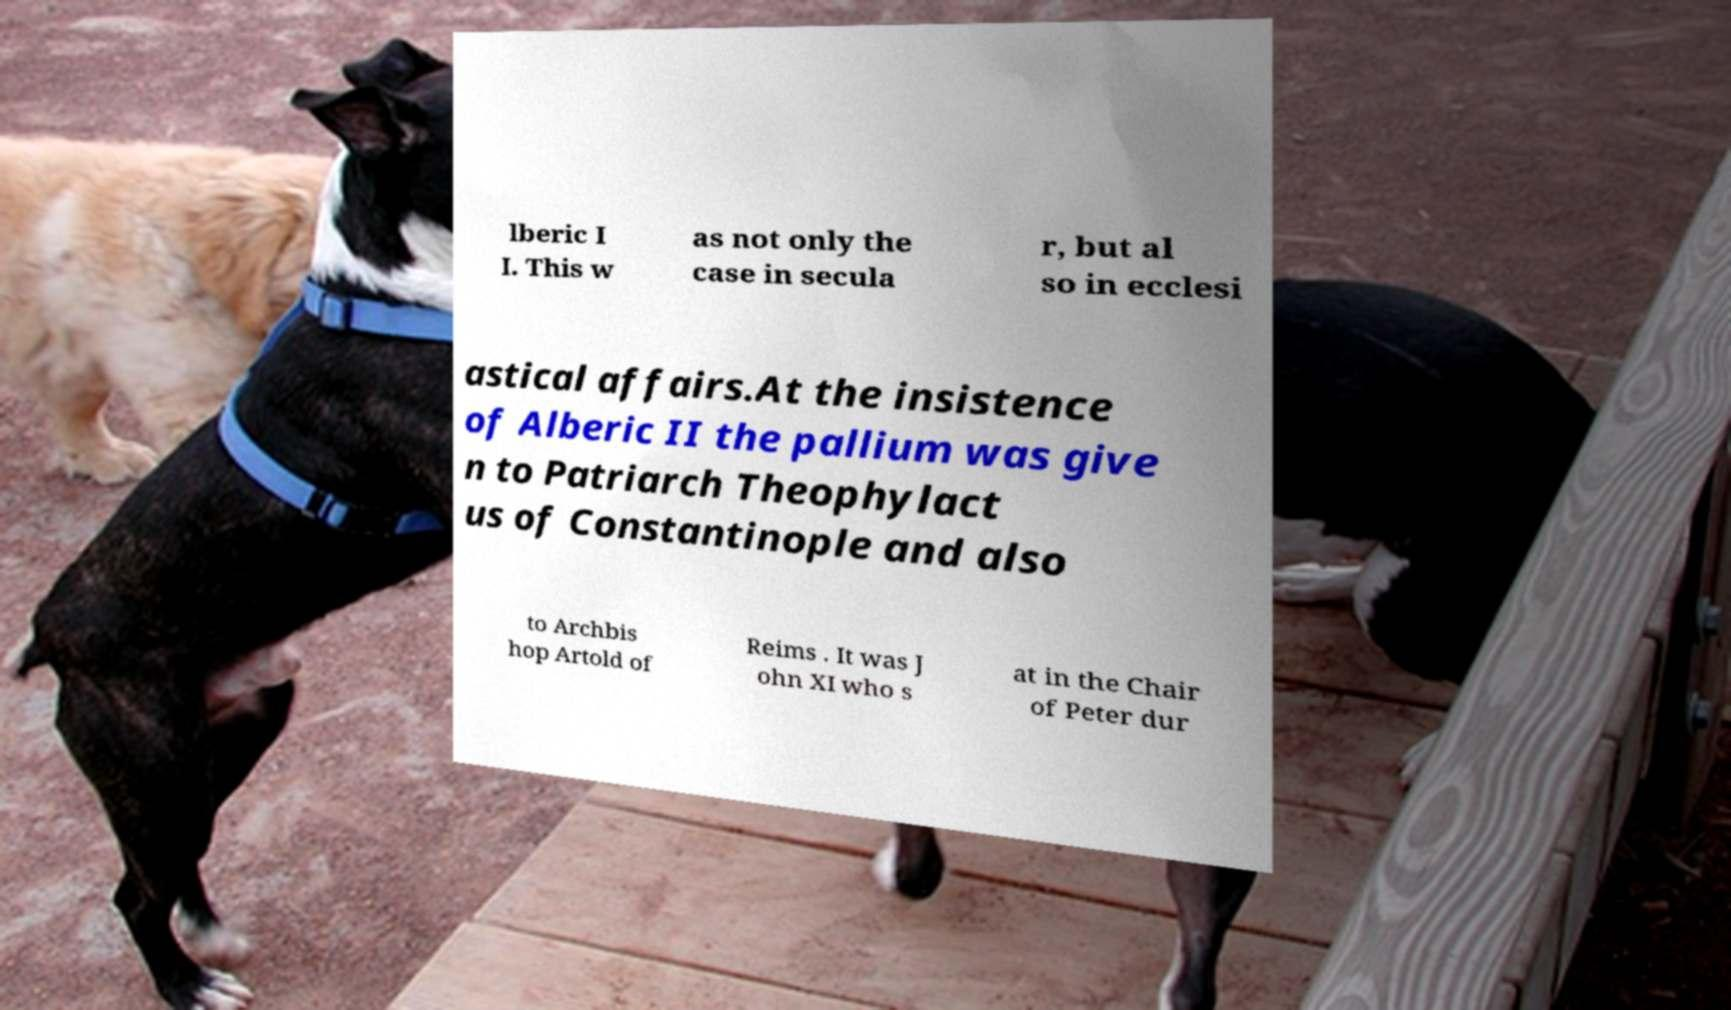What messages or text are displayed in this image? I need them in a readable, typed format. lberic I I. This w as not only the case in secula r, but al so in ecclesi astical affairs.At the insistence of Alberic II the pallium was give n to Patriarch Theophylact us of Constantinople and also to Archbis hop Artold of Reims . It was J ohn XI who s at in the Chair of Peter dur 